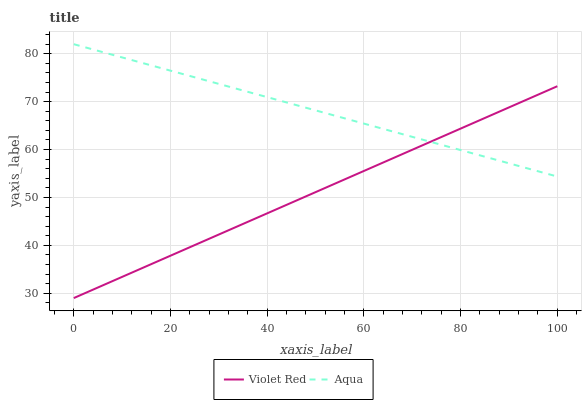Does Violet Red have the minimum area under the curve?
Answer yes or no. Yes. Does Aqua have the maximum area under the curve?
Answer yes or no. Yes. Does Aqua have the minimum area under the curve?
Answer yes or no. No. Is Aqua the smoothest?
Answer yes or no. Yes. Is Violet Red the roughest?
Answer yes or no. Yes. Is Aqua the roughest?
Answer yes or no. No. Does Violet Red have the lowest value?
Answer yes or no. Yes. Does Aqua have the lowest value?
Answer yes or no. No. Does Aqua have the highest value?
Answer yes or no. Yes. Does Aqua intersect Violet Red?
Answer yes or no. Yes. Is Aqua less than Violet Red?
Answer yes or no. No. Is Aqua greater than Violet Red?
Answer yes or no. No. 